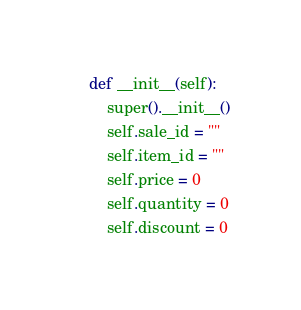Convert code to text. <code><loc_0><loc_0><loc_500><loc_500><_Python_>
    def __init__(self):
        super().__init__()
        self.sale_id = ""
        self.item_id = ""
        self.price = 0
        self.quantity = 0
        self.discount = 0
</code> 